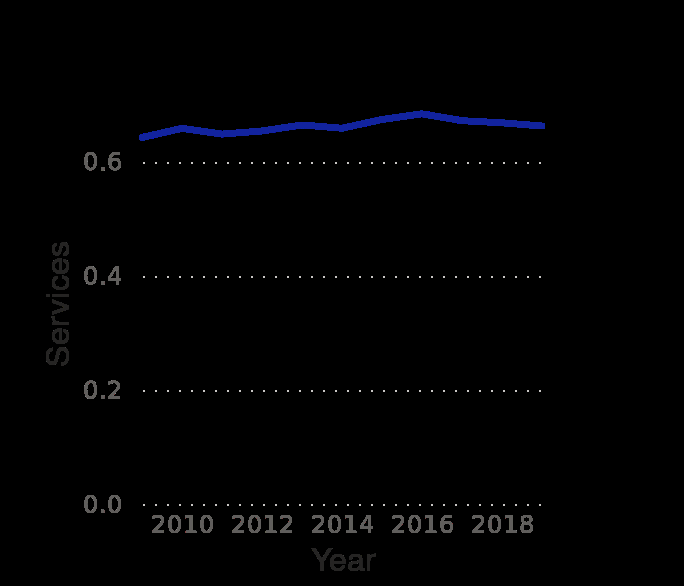<image>
Offer a thorough analysis of the image. Distribution of GDP has been consistent in the period of 2009-2019. There had been a slight fluctuation, but it typically corrects itself. What does the y-axis measure in the line chart? The y-axis measures Services in the line chart. During which years was there a significant increase in GDP?  Between 2014 and 2016, there was a bigger raise in GDP. How has the distribution been over the years?  The distribution has been more or less steady. 